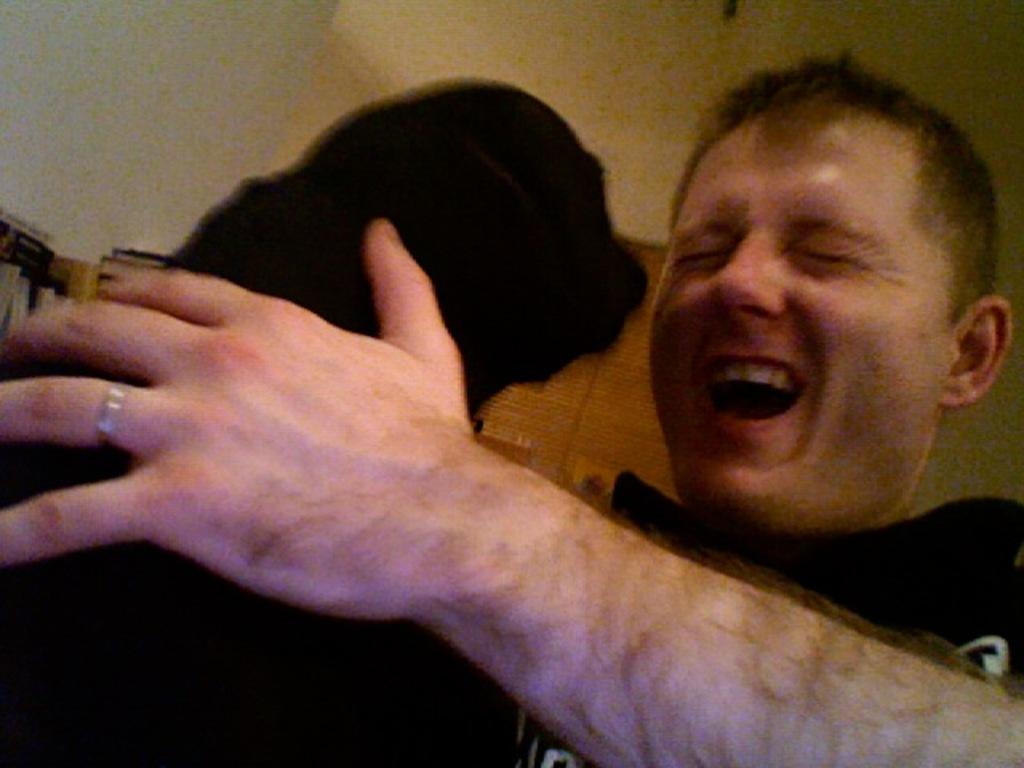Who or what is the main subject in the image? There is a person in the image. Can you describe the person's attire? The person is wearing a black dress. What other living creature is present in the image? There is an animal in the image. What is the color of the animal? The animal is black in color. What can be seen in the background of the image? There is a wall and a ceiling in the background of the image. What type of crime is being committed in the image? There is no indication of a crime being committed in the image. How many credit cards are visible in the image? There is no mention of credit cards in the image. 